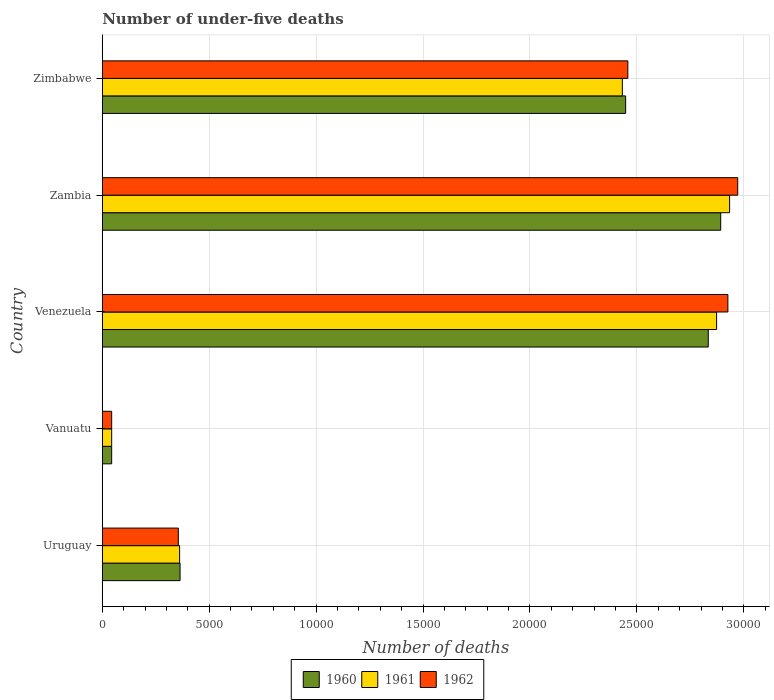How many groups of bars are there?
Offer a very short reply. 5. Are the number of bars on each tick of the Y-axis equal?
Offer a terse response. Yes. How many bars are there on the 5th tick from the top?
Provide a short and direct response. 3. How many bars are there on the 3rd tick from the bottom?
Offer a very short reply. 3. What is the label of the 1st group of bars from the top?
Offer a very short reply. Zimbabwe. In how many cases, is the number of bars for a given country not equal to the number of legend labels?
Provide a short and direct response. 0. What is the number of under-five deaths in 1962 in Venezuela?
Provide a short and direct response. 2.93e+04. Across all countries, what is the maximum number of under-five deaths in 1962?
Offer a very short reply. 2.97e+04. Across all countries, what is the minimum number of under-five deaths in 1960?
Your answer should be very brief. 441. In which country was the number of under-five deaths in 1962 maximum?
Your answer should be compact. Zambia. In which country was the number of under-five deaths in 1961 minimum?
Give a very brief answer. Vanuatu. What is the total number of under-five deaths in 1962 in the graph?
Your answer should be very brief. 8.75e+04. What is the difference between the number of under-five deaths in 1962 in Zambia and that in Zimbabwe?
Make the answer very short. 5138. What is the difference between the number of under-five deaths in 1962 in Zimbabwe and the number of under-five deaths in 1961 in Vanuatu?
Provide a short and direct response. 2.41e+04. What is the average number of under-five deaths in 1960 per country?
Make the answer very short. 1.72e+04. What is the difference between the number of under-five deaths in 1960 and number of under-five deaths in 1961 in Zimbabwe?
Your response must be concise. 154. In how many countries, is the number of under-five deaths in 1962 greater than 10000 ?
Provide a succinct answer. 3. What is the ratio of the number of under-five deaths in 1962 in Uruguay to that in Zambia?
Your answer should be compact. 0.12. What is the difference between the highest and the second highest number of under-five deaths in 1962?
Your response must be concise. 460. What is the difference between the highest and the lowest number of under-five deaths in 1962?
Ensure brevity in your answer.  2.93e+04. What does the 3rd bar from the top in Vanuatu represents?
Provide a short and direct response. 1960. Is it the case that in every country, the sum of the number of under-five deaths in 1960 and number of under-five deaths in 1961 is greater than the number of under-five deaths in 1962?
Offer a terse response. Yes. How many bars are there?
Provide a short and direct response. 15. How many countries are there in the graph?
Your answer should be very brief. 5. Are the values on the major ticks of X-axis written in scientific E-notation?
Keep it short and to the point. No. Where does the legend appear in the graph?
Your response must be concise. Bottom center. How are the legend labels stacked?
Keep it short and to the point. Horizontal. What is the title of the graph?
Offer a very short reply. Number of under-five deaths. Does "2007" appear as one of the legend labels in the graph?
Provide a short and direct response. No. What is the label or title of the X-axis?
Offer a very short reply. Number of deaths. What is the label or title of the Y-axis?
Provide a succinct answer. Country. What is the Number of deaths in 1960 in Uruguay?
Give a very brief answer. 3639. What is the Number of deaths of 1961 in Uruguay?
Your response must be concise. 3618. What is the Number of deaths in 1962 in Uruguay?
Keep it short and to the point. 3557. What is the Number of deaths in 1960 in Vanuatu?
Provide a short and direct response. 441. What is the Number of deaths of 1961 in Vanuatu?
Provide a short and direct response. 441. What is the Number of deaths of 1962 in Vanuatu?
Offer a very short reply. 441. What is the Number of deaths of 1960 in Venezuela?
Make the answer very short. 2.83e+04. What is the Number of deaths of 1961 in Venezuela?
Give a very brief answer. 2.87e+04. What is the Number of deaths of 1962 in Venezuela?
Your answer should be very brief. 2.93e+04. What is the Number of deaths in 1960 in Zambia?
Give a very brief answer. 2.89e+04. What is the Number of deaths in 1961 in Zambia?
Provide a succinct answer. 2.93e+04. What is the Number of deaths in 1962 in Zambia?
Make the answer very short. 2.97e+04. What is the Number of deaths in 1960 in Zimbabwe?
Your answer should be compact. 2.45e+04. What is the Number of deaths of 1961 in Zimbabwe?
Your response must be concise. 2.43e+04. What is the Number of deaths in 1962 in Zimbabwe?
Offer a very short reply. 2.46e+04. Across all countries, what is the maximum Number of deaths of 1960?
Give a very brief answer. 2.89e+04. Across all countries, what is the maximum Number of deaths in 1961?
Make the answer very short. 2.93e+04. Across all countries, what is the maximum Number of deaths in 1962?
Provide a short and direct response. 2.97e+04. Across all countries, what is the minimum Number of deaths of 1960?
Keep it short and to the point. 441. Across all countries, what is the minimum Number of deaths in 1961?
Offer a very short reply. 441. Across all countries, what is the minimum Number of deaths of 1962?
Ensure brevity in your answer.  441. What is the total Number of deaths in 1960 in the graph?
Make the answer very short. 8.58e+04. What is the total Number of deaths in 1961 in the graph?
Offer a very short reply. 8.64e+04. What is the total Number of deaths in 1962 in the graph?
Your answer should be compact. 8.75e+04. What is the difference between the Number of deaths in 1960 in Uruguay and that in Vanuatu?
Make the answer very short. 3198. What is the difference between the Number of deaths in 1961 in Uruguay and that in Vanuatu?
Make the answer very short. 3177. What is the difference between the Number of deaths of 1962 in Uruguay and that in Vanuatu?
Offer a very short reply. 3116. What is the difference between the Number of deaths of 1960 in Uruguay and that in Venezuela?
Offer a very short reply. -2.47e+04. What is the difference between the Number of deaths in 1961 in Uruguay and that in Venezuela?
Offer a terse response. -2.51e+04. What is the difference between the Number of deaths of 1962 in Uruguay and that in Venezuela?
Your answer should be very brief. -2.57e+04. What is the difference between the Number of deaths of 1960 in Uruguay and that in Zambia?
Your answer should be compact. -2.53e+04. What is the difference between the Number of deaths in 1961 in Uruguay and that in Zambia?
Your response must be concise. -2.57e+04. What is the difference between the Number of deaths of 1962 in Uruguay and that in Zambia?
Offer a very short reply. -2.62e+04. What is the difference between the Number of deaths in 1960 in Uruguay and that in Zimbabwe?
Provide a short and direct response. -2.08e+04. What is the difference between the Number of deaths of 1961 in Uruguay and that in Zimbabwe?
Your answer should be very brief. -2.07e+04. What is the difference between the Number of deaths in 1962 in Uruguay and that in Zimbabwe?
Provide a short and direct response. -2.10e+04. What is the difference between the Number of deaths of 1960 in Vanuatu and that in Venezuela?
Your answer should be compact. -2.79e+04. What is the difference between the Number of deaths of 1961 in Vanuatu and that in Venezuela?
Make the answer very short. -2.83e+04. What is the difference between the Number of deaths in 1962 in Vanuatu and that in Venezuela?
Your answer should be compact. -2.88e+04. What is the difference between the Number of deaths of 1960 in Vanuatu and that in Zambia?
Offer a very short reply. -2.85e+04. What is the difference between the Number of deaths in 1961 in Vanuatu and that in Zambia?
Offer a terse response. -2.89e+04. What is the difference between the Number of deaths in 1962 in Vanuatu and that in Zambia?
Keep it short and to the point. -2.93e+04. What is the difference between the Number of deaths in 1960 in Vanuatu and that in Zimbabwe?
Offer a terse response. -2.40e+04. What is the difference between the Number of deaths of 1961 in Vanuatu and that in Zimbabwe?
Offer a terse response. -2.39e+04. What is the difference between the Number of deaths of 1962 in Vanuatu and that in Zimbabwe?
Offer a very short reply. -2.41e+04. What is the difference between the Number of deaths of 1960 in Venezuela and that in Zambia?
Your response must be concise. -582. What is the difference between the Number of deaths in 1961 in Venezuela and that in Zambia?
Offer a terse response. -608. What is the difference between the Number of deaths in 1962 in Venezuela and that in Zambia?
Give a very brief answer. -460. What is the difference between the Number of deaths of 1960 in Venezuela and that in Zimbabwe?
Provide a succinct answer. 3864. What is the difference between the Number of deaths in 1961 in Venezuela and that in Zimbabwe?
Provide a short and direct response. 4408. What is the difference between the Number of deaths in 1962 in Venezuela and that in Zimbabwe?
Offer a very short reply. 4678. What is the difference between the Number of deaths in 1960 in Zambia and that in Zimbabwe?
Give a very brief answer. 4446. What is the difference between the Number of deaths of 1961 in Zambia and that in Zimbabwe?
Offer a terse response. 5016. What is the difference between the Number of deaths in 1962 in Zambia and that in Zimbabwe?
Make the answer very short. 5138. What is the difference between the Number of deaths in 1960 in Uruguay and the Number of deaths in 1961 in Vanuatu?
Keep it short and to the point. 3198. What is the difference between the Number of deaths in 1960 in Uruguay and the Number of deaths in 1962 in Vanuatu?
Your answer should be very brief. 3198. What is the difference between the Number of deaths of 1961 in Uruguay and the Number of deaths of 1962 in Vanuatu?
Provide a short and direct response. 3177. What is the difference between the Number of deaths of 1960 in Uruguay and the Number of deaths of 1961 in Venezuela?
Offer a terse response. -2.51e+04. What is the difference between the Number of deaths of 1960 in Uruguay and the Number of deaths of 1962 in Venezuela?
Offer a very short reply. -2.56e+04. What is the difference between the Number of deaths in 1961 in Uruguay and the Number of deaths in 1962 in Venezuela?
Offer a terse response. -2.56e+04. What is the difference between the Number of deaths of 1960 in Uruguay and the Number of deaths of 1961 in Zambia?
Provide a succinct answer. -2.57e+04. What is the difference between the Number of deaths in 1960 in Uruguay and the Number of deaths in 1962 in Zambia?
Offer a terse response. -2.61e+04. What is the difference between the Number of deaths of 1961 in Uruguay and the Number of deaths of 1962 in Zambia?
Provide a short and direct response. -2.61e+04. What is the difference between the Number of deaths of 1960 in Uruguay and the Number of deaths of 1961 in Zimbabwe?
Provide a succinct answer. -2.07e+04. What is the difference between the Number of deaths of 1960 in Uruguay and the Number of deaths of 1962 in Zimbabwe?
Your answer should be very brief. -2.09e+04. What is the difference between the Number of deaths of 1961 in Uruguay and the Number of deaths of 1962 in Zimbabwe?
Your answer should be very brief. -2.10e+04. What is the difference between the Number of deaths of 1960 in Vanuatu and the Number of deaths of 1961 in Venezuela?
Your answer should be compact. -2.83e+04. What is the difference between the Number of deaths of 1960 in Vanuatu and the Number of deaths of 1962 in Venezuela?
Keep it short and to the point. -2.88e+04. What is the difference between the Number of deaths in 1961 in Vanuatu and the Number of deaths in 1962 in Venezuela?
Offer a very short reply. -2.88e+04. What is the difference between the Number of deaths in 1960 in Vanuatu and the Number of deaths in 1961 in Zambia?
Provide a succinct answer. -2.89e+04. What is the difference between the Number of deaths of 1960 in Vanuatu and the Number of deaths of 1962 in Zambia?
Make the answer very short. -2.93e+04. What is the difference between the Number of deaths in 1961 in Vanuatu and the Number of deaths in 1962 in Zambia?
Give a very brief answer. -2.93e+04. What is the difference between the Number of deaths in 1960 in Vanuatu and the Number of deaths in 1961 in Zimbabwe?
Offer a very short reply. -2.39e+04. What is the difference between the Number of deaths of 1960 in Vanuatu and the Number of deaths of 1962 in Zimbabwe?
Give a very brief answer. -2.41e+04. What is the difference between the Number of deaths in 1961 in Vanuatu and the Number of deaths in 1962 in Zimbabwe?
Your answer should be compact. -2.41e+04. What is the difference between the Number of deaths in 1960 in Venezuela and the Number of deaths in 1961 in Zambia?
Give a very brief answer. -998. What is the difference between the Number of deaths in 1960 in Venezuela and the Number of deaths in 1962 in Zambia?
Keep it short and to the point. -1377. What is the difference between the Number of deaths of 1961 in Venezuela and the Number of deaths of 1962 in Zambia?
Your response must be concise. -987. What is the difference between the Number of deaths in 1960 in Venezuela and the Number of deaths in 1961 in Zimbabwe?
Your answer should be very brief. 4018. What is the difference between the Number of deaths in 1960 in Venezuela and the Number of deaths in 1962 in Zimbabwe?
Your answer should be very brief. 3761. What is the difference between the Number of deaths of 1961 in Venezuela and the Number of deaths of 1962 in Zimbabwe?
Give a very brief answer. 4151. What is the difference between the Number of deaths of 1960 in Zambia and the Number of deaths of 1961 in Zimbabwe?
Ensure brevity in your answer.  4600. What is the difference between the Number of deaths in 1960 in Zambia and the Number of deaths in 1962 in Zimbabwe?
Keep it short and to the point. 4343. What is the difference between the Number of deaths of 1961 in Zambia and the Number of deaths of 1962 in Zimbabwe?
Your response must be concise. 4759. What is the average Number of deaths in 1960 per country?
Your answer should be very brief. 1.72e+04. What is the average Number of deaths in 1961 per country?
Offer a very short reply. 1.73e+04. What is the average Number of deaths of 1962 per country?
Your answer should be very brief. 1.75e+04. What is the difference between the Number of deaths of 1960 and Number of deaths of 1961 in Vanuatu?
Give a very brief answer. 0. What is the difference between the Number of deaths in 1960 and Number of deaths in 1962 in Vanuatu?
Offer a terse response. 0. What is the difference between the Number of deaths in 1960 and Number of deaths in 1961 in Venezuela?
Provide a succinct answer. -390. What is the difference between the Number of deaths in 1960 and Number of deaths in 1962 in Venezuela?
Your response must be concise. -917. What is the difference between the Number of deaths in 1961 and Number of deaths in 1962 in Venezuela?
Ensure brevity in your answer.  -527. What is the difference between the Number of deaths in 1960 and Number of deaths in 1961 in Zambia?
Your answer should be compact. -416. What is the difference between the Number of deaths of 1960 and Number of deaths of 1962 in Zambia?
Keep it short and to the point. -795. What is the difference between the Number of deaths of 1961 and Number of deaths of 1962 in Zambia?
Ensure brevity in your answer.  -379. What is the difference between the Number of deaths of 1960 and Number of deaths of 1961 in Zimbabwe?
Offer a terse response. 154. What is the difference between the Number of deaths in 1960 and Number of deaths in 1962 in Zimbabwe?
Make the answer very short. -103. What is the difference between the Number of deaths of 1961 and Number of deaths of 1962 in Zimbabwe?
Provide a succinct answer. -257. What is the ratio of the Number of deaths in 1960 in Uruguay to that in Vanuatu?
Provide a succinct answer. 8.25. What is the ratio of the Number of deaths in 1961 in Uruguay to that in Vanuatu?
Ensure brevity in your answer.  8.2. What is the ratio of the Number of deaths of 1962 in Uruguay to that in Vanuatu?
Offer a terse response. 8.07. What is the ratio of the Number of deaths in 1960 in Uruguay to that in Venezuela?
Give a very brief answer. 0.13. What is the ratio of the Number of deaths in 1961 in Uruguay to that in Venezuela?
Offer a terse response. 0.13. What is the ratio of the Number of deaths in 1962 in Uruguay to that in Venezuela?
Make the answer very short. 0.12. What is the ratio of the Number of deaths in 1960 in Uruguay to that in Zambia?
Your answer should be compact. 0.13. What is the ratio of the Number of deaths in 1961 in Uruguay to that in Zambia?
Provide a succinct answer. 0.12. What is the ratio of the Number of deaths of 1962 in Uruguay to that in Zambia?
Make the answer very short. 0.12. What is the ratio of the Number of deaths in 1960 in Uruguay to that in Zimbabwe?
Offer a very short reply. 0.15. What is the ratio of the Number of deaths in 1961 in Uruguay to that in Zimbabwe?
Offer a very short reply. 0.15. What is the ratio of the Number of deaths in 1962 in Uruguay to that in Zimbabwe?
Keep it short and to the point. 0.14. What is the ratio of the Number of deaths in 1960 in Vanuatu to that in Venezuela?
Provide a short and direct response. 0.02. What is the ratio of the Number of deaths of 1961 in Vanuatu to that in Venezuela?
Keep it short and to the point. 0.02. What is the ratio of the Number of deaths of 1962 in Vanuatu to that in Venezuela?
Your answer should be very brief. 0.02. What is the ratio of the Number of deaths in 1960 in Vanuatu to that in Zambia?
Provide a short and direct response. 0.02. What is the ratio of the Number of deaths of 1961 in Vanuatu to that in Zambia?
Make the answer very short. 0.01. What is the ratio of the Number of deaths of 1962 in Vanuatu to that in Zambia?
Ensure brevity in your answer.  0.01. What is the ratio of the Number of deaths of 1960 in Vanuatu to that in Zimbabwe?
Give a very brief answer. 0.02. What is the ratio of the Number of deaths of 1961 in Vanuatu to that in Zimbabwe?
Ensure brevity in your answer.  0.02. What is the ratio of the Number of deaths of 1962 in Vanuatu to that in Zimbabwe?
Your answer should be very brief. 0.02. What is the ratio of the Number of deaths of 1960 in Venezuela to that in Zambia?
Give a very brief answer. 0.98. What is the ratio of the Number of deaths of 1961 in Venezuela to that in Zambia?
Keep it short and to the point. 0.98. What is the ratio of the Number of deaths of 1962 in Venezuela to that in Zambia?
Offer a terse response. 0.98. What is the ratio of the Number of deaths in 1960 in Venezuela to that in Zimbabwe?
Provide a short and direct response. 1.16. What is the ratio of the Number of deaths of 1961 in Venezuela to that in Zimbabwe?
Your answer should be compact. 1.18. What is the ratio of the Number of deaths in 1962 in Venezuela to that in Zimbabwe?
Provide a short and direct response. 1.19. What is the ratio of the Number of deaths in 1960 in Zambia to that in Zimbabwe?
Ensure brevity in your answer.  1.18. What is the ratio of the Number of deaths of 1961 in Zambia to that in Zimbabwe?
Ensure brevity in your answer.  1.21. What is the ratio of the Number of deaths in 1962 in Zambia to that in Zimbabwe?
Give a very brief answer. 1.21. What is the difference between the highest and the second highest Number of deaths of 1960?
Give a very brief answer. 582. What is the difference between the highest and the second highest Number of deaths in 1961?
Offer a terse response. 608. What is the difference between the highest and the second highest Number of deaths of 1962?
Ensure brevity in your answer.  460. What is the difference between the highest and the lowest Number of deaths of 1960?
Your response must be concise. 2.85e+04. What is the difference between the highest and the lowest Number of deaths of 1961?
Your answer should be compact. 2.89e+04. What is the difference between the highest and the lowest Number of deaths of 1962?
Offer a very short reply. 2.93e+04. 